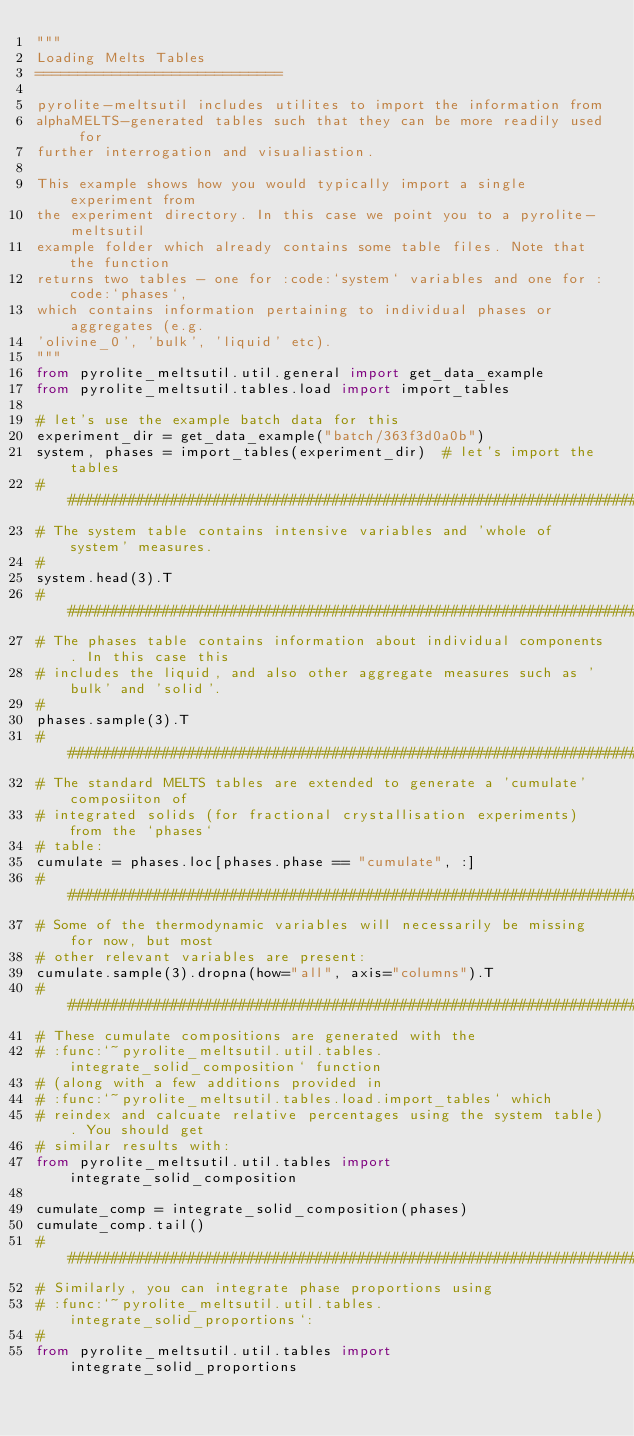Convert code to text. <code><loc_0><loc_0><loc_500><loc_500><_Python_>"""
Loading Melts Tables
=============================

pyrolite-meltsutil includes utilites to import the information from
alphaMELTS-generated tables such that they can be more readily used for
further interrogation and visualiastion.

This example shows how you would typically import a single experiment from
the experiment directory. In this case we point you to a pyrolite-meltsutil
example folder which already contains some table files. Note that the function
returns two tables - one for :code:`system` variables and one for :code:`phases`,
which contains information pertaining to individual phases or aggregates (e.g.
'olivine_0', 'bulk', 'liquid' etc).
"""
from pyrolite_meltsutil.util.general import get_data_example
from pyrolite_meltsutil.tables.load import import_tables

# let's use the example batch data for this
experiment_dir = get_data_example("batch/363f3d0a0b")
system, phases = import_tables(experiment_dir)  # let's import the tables
########################################################################################
# The system table contains intensive variables and 'whole of system' measures.
#
system.head(3).T
########################################################################################
# The phases table contains information about individual components. In this case this
# includes the liquid, and also other aggregate measures such as 'bulk' and 'solid'.
#
phases.sample(3).T
########################################################################################
# The standard MELTS tables are extended to generate a 'cumulate' composiiton of
# integrated solids (for fractional crystallisation experiments) from the `phases`
# table:
cumulate = phases.loc[phases.phase == "cumulate", :]
########################################################################################
# Some of the thermodynamic variables will necessarily be missing for now, but most
# other relevant variables are present:
cumulate.sample(3).dropna(how="all", axis="columns").T
########################################################################################
# These cumulate compositions are generated with the
# :func:`~pyrolite_meltsutil.util.tables.integrate_solid_composition` function
# (along with a few additions provided in
# :func:`~pyrolite_meltsutil.tables.load.import_tables` which
# reindex and calcuate relative percentages using the system table). You should get
# similar results with:
from pyrolite_meltsutil.util.tables import integrate_solid_composition

cumulate_comp = integrate_solid_composition(phases)
cumulate_comp.tail()
#########################################################################################
# Similarly, you can integrate phase proportions using
# :func:`~pyrolite_meltsutil.util.tables.integrate_solid_proportions`:
#
from pyrolite_meltsutil.util.tables import integrate_solid_proportions
</code> 